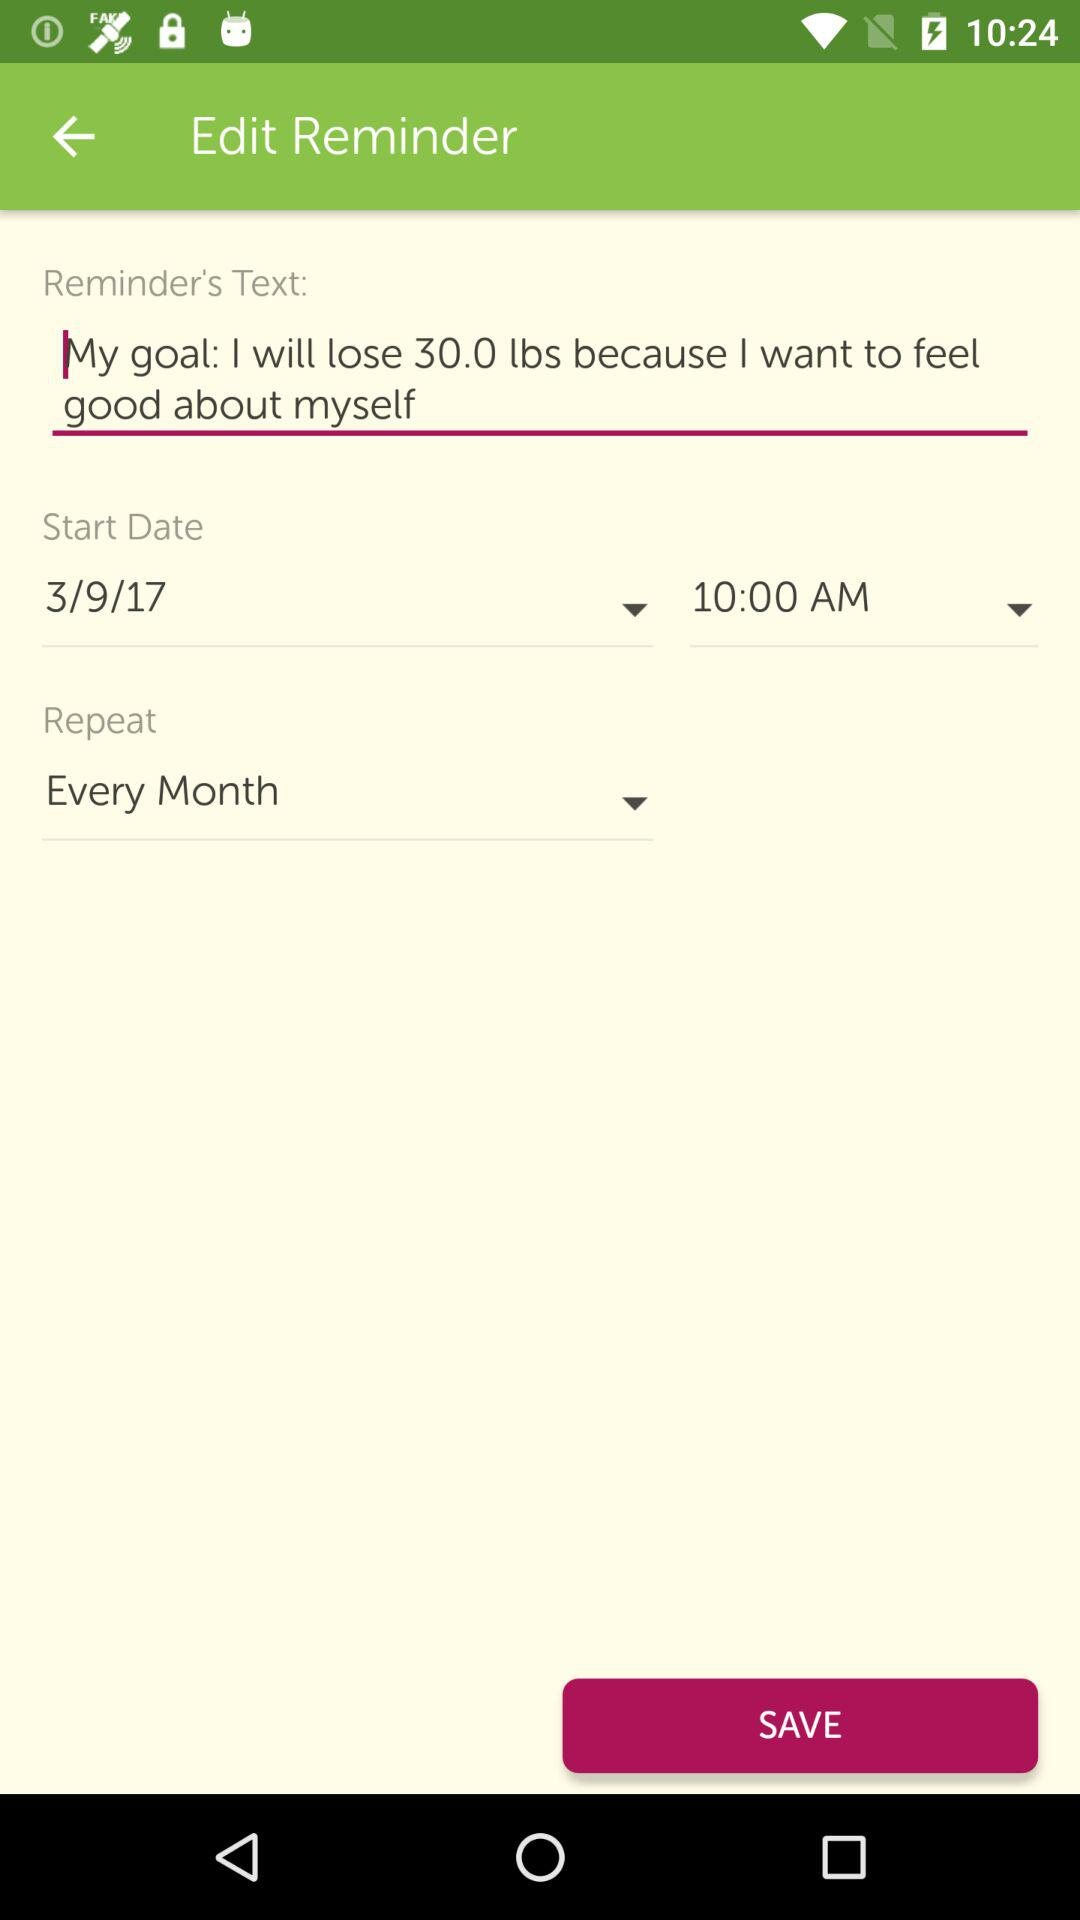What is the selected repeat cycle? The selected repeat cycle is "Every Month". 